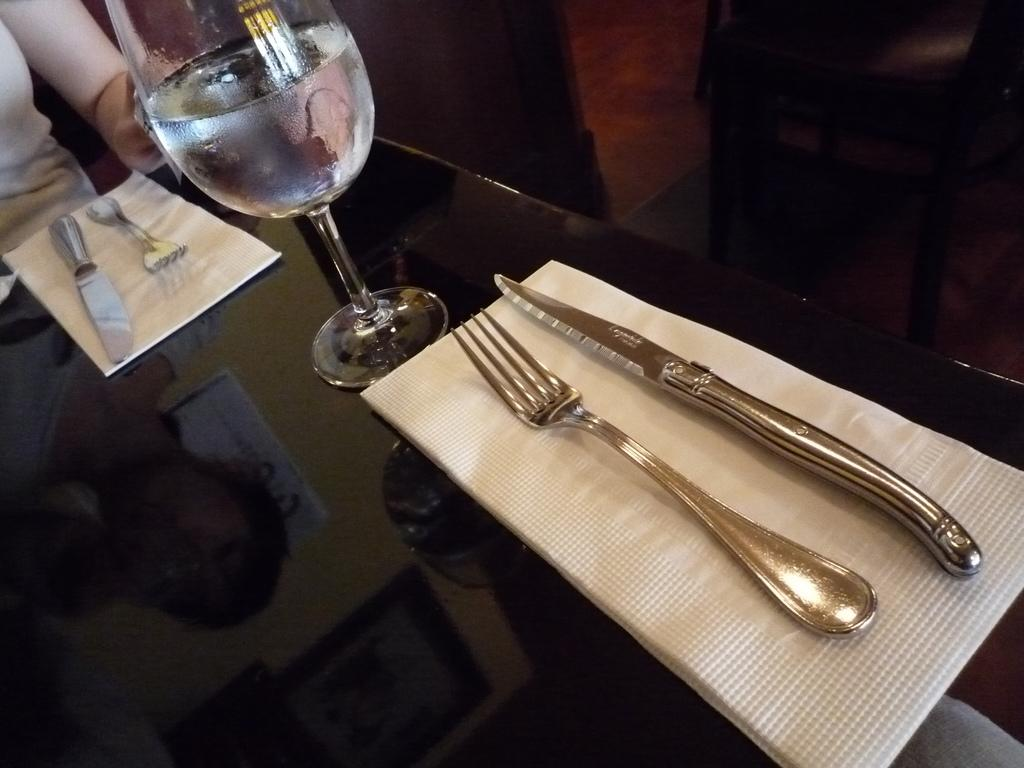What piece of furniture is present in the image? There is a table in the image. What is placed on the table? There is a glass, forks, and knives on the table. Who is present in the image? A person is sitting in front of the table. What type of money is visible on the table in the image? There is no money visible on the table in the image. Can you hear the robin singing in the image? There is no robin or any sound mentioned in the image, so it is not possible to answer that question. 